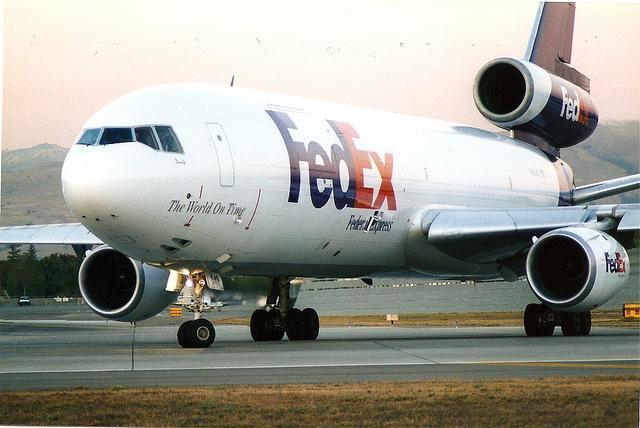How many engines can be seen at this angle?
Give a very brief answer. 3. 